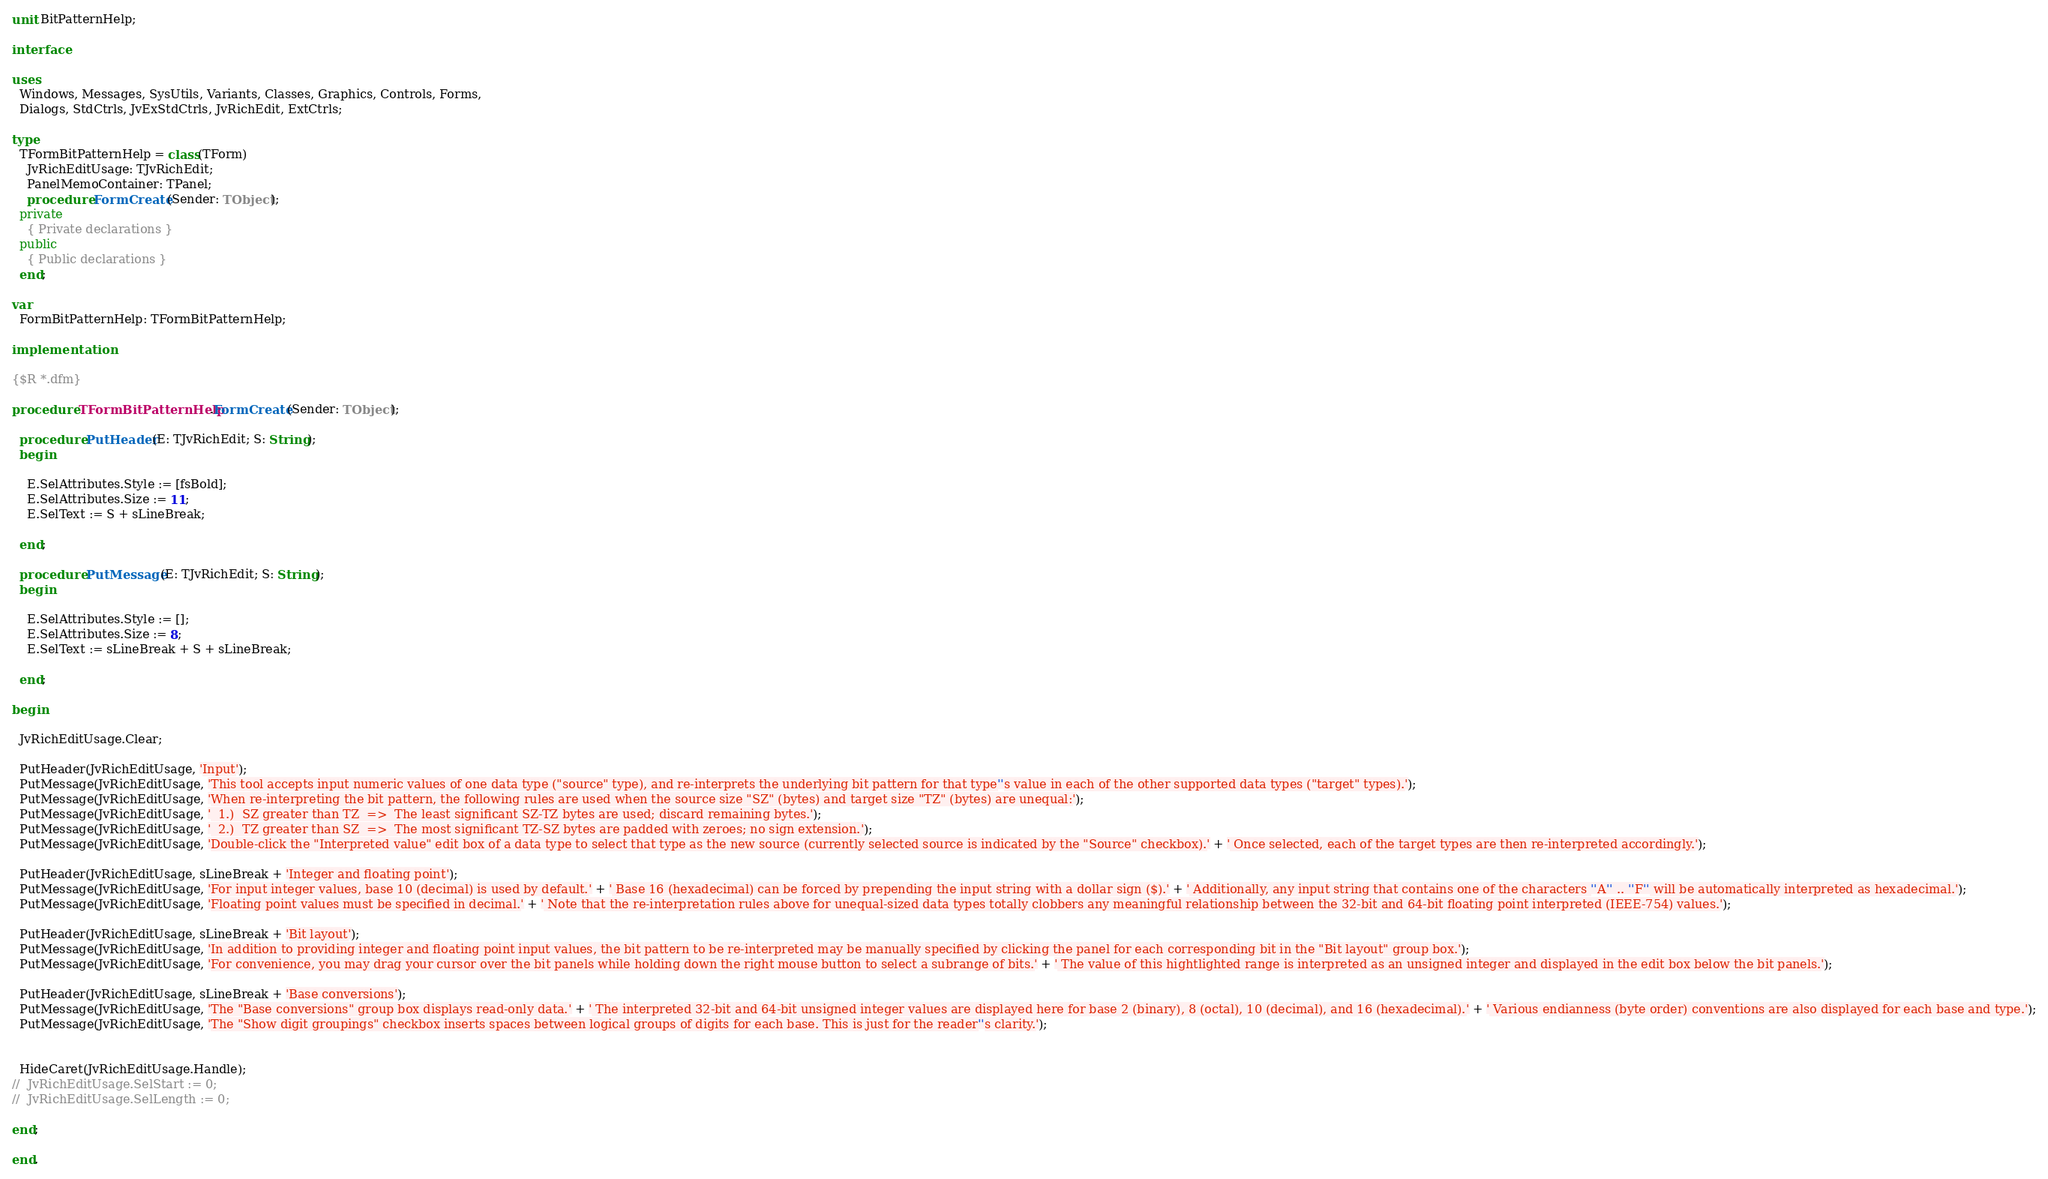<code> <loc_0><loc_0><loc_500><loc_500><_Pascal_>unit BitPatternHelp;

interface

uses
  Windows, Messages, SysUtils, Variants, Classes, Graphics, Controls, Forms,
  Dialogs, StdCtrls, JvExStdCtrls, JvRichEdit, ExtCtrls;

type
  TFormBitPatternHelp = class(TForm)
    JvRichEditUsage: TJvRichEdit;
    PanelMemoContainer: TPanel;
    procedure FormCreate(Sender: TObject);
  private
    { Private declarations }
  public
    { Public declarations }
  end;

var
  FormBitPatternHelp: TFormBitPatternHelp;

implementation

{$R *.dfm}

procedure TFormBitPatternHelp.FormCreate(Sender: TObject);

  procedure PutHeader(E: TJvRichEdit; S: String);
  begin

    E.SelAttributes.Style := [fsBold];
    E.SelAttributes.Size := 11;
    E.SelText := S + sLineBreak;

  end;

  procedure PutMessage(E: TJvRichEdit; S: String);
  begin

    E.SelAttributes.Style := [];
    E.SelAttributes.Size := 8;
    E.SelText := sLineBreak + S + sLineBreak;

  end;

begin

  JvRichEditUsage.Clear;

  PutHeader(JvRichEditUsage, 'Input');
  PutMessage(JvRichEditUsage, 'This tool accepts input numeric values of one data type ("source" type), and re-interprets the underlying bit pattern for that type''s value in each of the other supported data types ("target" types).');
  PutMessage(JvRichEditUsage, 'When re-interpreting the bit pattern, the following rules are used when the source size "SZ" (bytes) and target size "TZ" (bytes) are unequal:');
  PutMessage(JvRichEditUsage, '  1.)  SZ greater than TZ  =>  The least significant SZ-TZ bytes are used; discard remaining bytes.');
  PutMessage(JvRichEditUsage, '  2.)  TZ greater than SZ  =>  The most significant TZ-SZ bytes are padded with zeroes; no sign extension.');
  PutMessage(JvRichEditUsage, 'Double-click the "Interpreted value" edit box of a data type to select that type as the new source (currently selected source is indicated by the "Source" checkbox).' + ' Once selected, each of the target types are then re-interpreted accordingly.');

  PutHeader(JvRichEditUsage, sLineBreak + 'Integer and floating point');
  PutMessage(JvRichEditUsage, 'For input integer values, base 10 (decimal) is used by default.' + ' Base 16 (hexadecimal) can be forced by prepending the input string with a dollar sign ($).' + ' Additionally, any input string that contains one of the characters ''A'' .. ''F'' will be automatically interpreted as hexadecimal.');
  PutMessage(JvRichEditUsage, 'Floating point values must be specified in decimal.' + ' Note that the re-interpretation rules above for unequal-sized data types totally clobbers any meaningful relationship between the 32-bit and 64-bit floating point interpreted (IEEE-754) values.');

  PutHeader(JvRichEditUsage, sLineBreak + 'Bit layout');
  PutMessage(JvRichEditUsage, 'In addition to providing integer and floating point input values, the bit pattern to be re-interpreted may be manually specified by clicking the panel for each corresponding bit in the "Bit layout" group box.');
  PutMessage(JvRichEditUsage, 'For convenience, you may drag your cursor over the bit panels while holding down the right mouse button to select a subrange of bits.' + ' The value of this hightlighted range is interpreted as an unsigned integer and displayed in the edit box below the bit panels.');

  PutHeader(JvRichEditUsage, sLineBreak + 'Base conversions');
  PutMessage(JvRichEditUsage, 'The "Base conversions" group box displays read-only data.' + ' The interpreted 32-bit and 64-bit unsigned integer values are displayed here for base 2 (binary), 8 (octal), 10 (decimal), and 16 (hexadecimal).' + ' Various endianness (byte order) conventions are also displayed for each base and type.');
  PutMessage(JvRichEditUsage, 'The "Show digit groupings" checkbox inserts spaces between logical groups of digits for each base. This is just for the reader''s clarity.');


  HideCaret(JvRichEditUsage.Handle);
//  JvRichEditUsage.SelStart := 0;
//  JvRichEditUsage.SelLength := 0;

end;

end.
</code> 